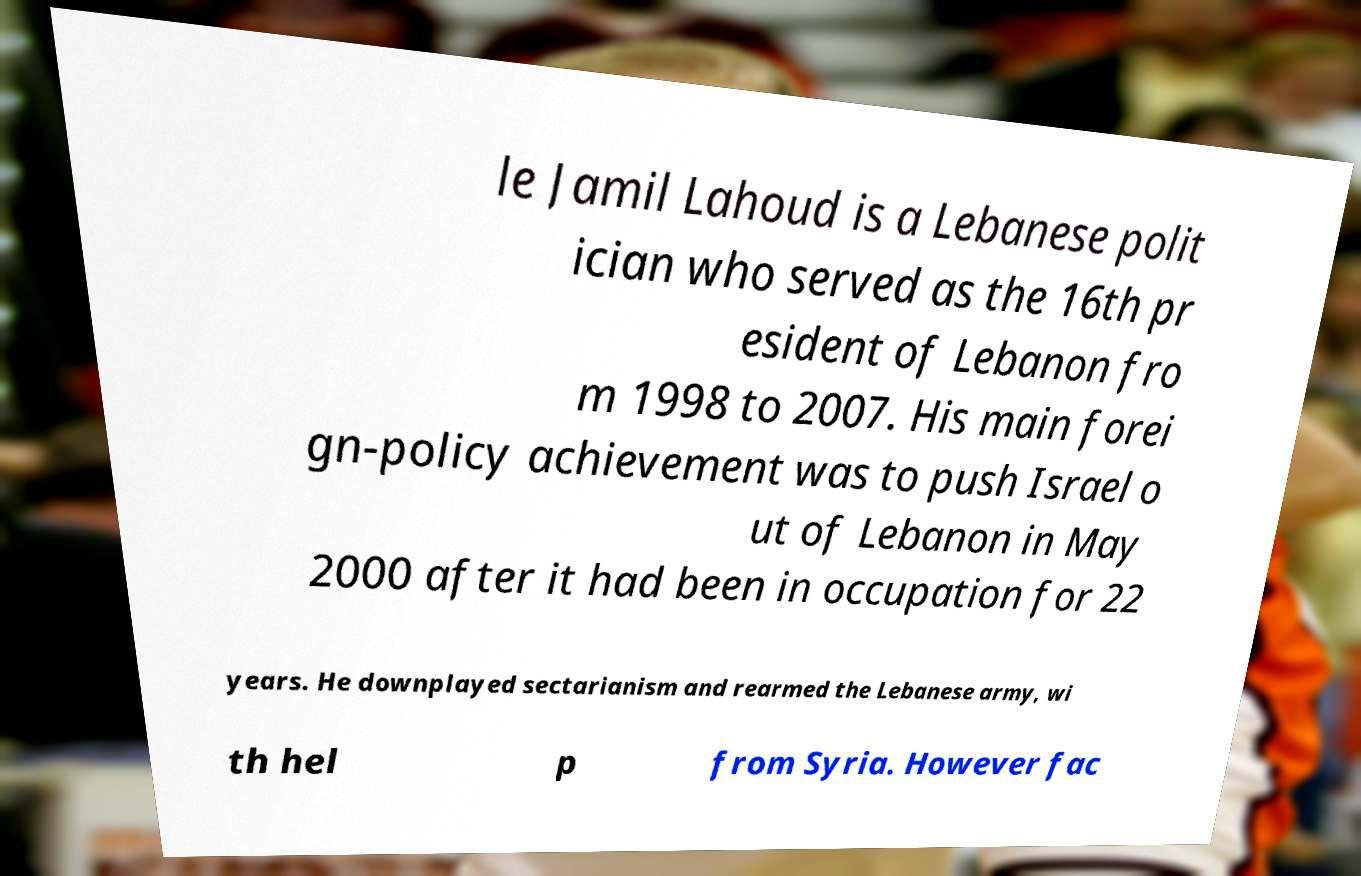Please read and relay the text visible in this image. What does it say? le Jamil Lahoud is a Lebanese polit ician who served as the 16th pr esident of Lebanon fro m 1998 to 2007. His main forei gn-policy achievement was to push Israel o ut of Lebanon in May 2000 after it had been in occupation for 22 years. He downplayed sectarianism and rearmed the Lebanese army, wi th hel p from Syria. However fac 